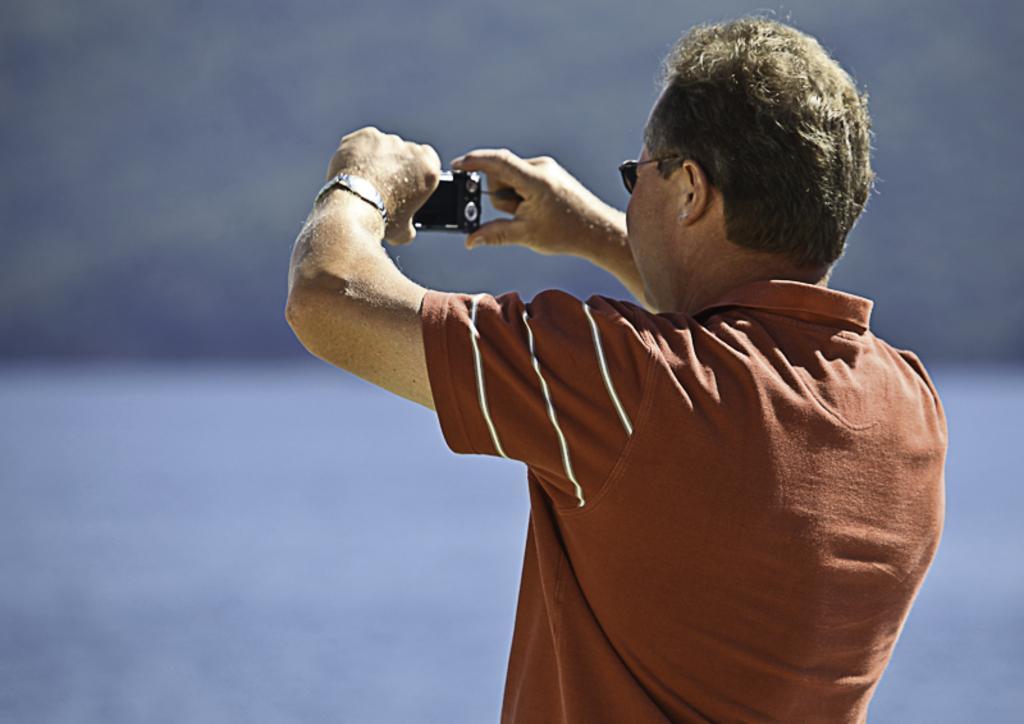Please provide a concise description of this image. In the center of the image we can see one person is standing and he is holding a camera. And he is wearing sunglasses and he is in the brown color t shirt. In the background, we can see it is blurred. 